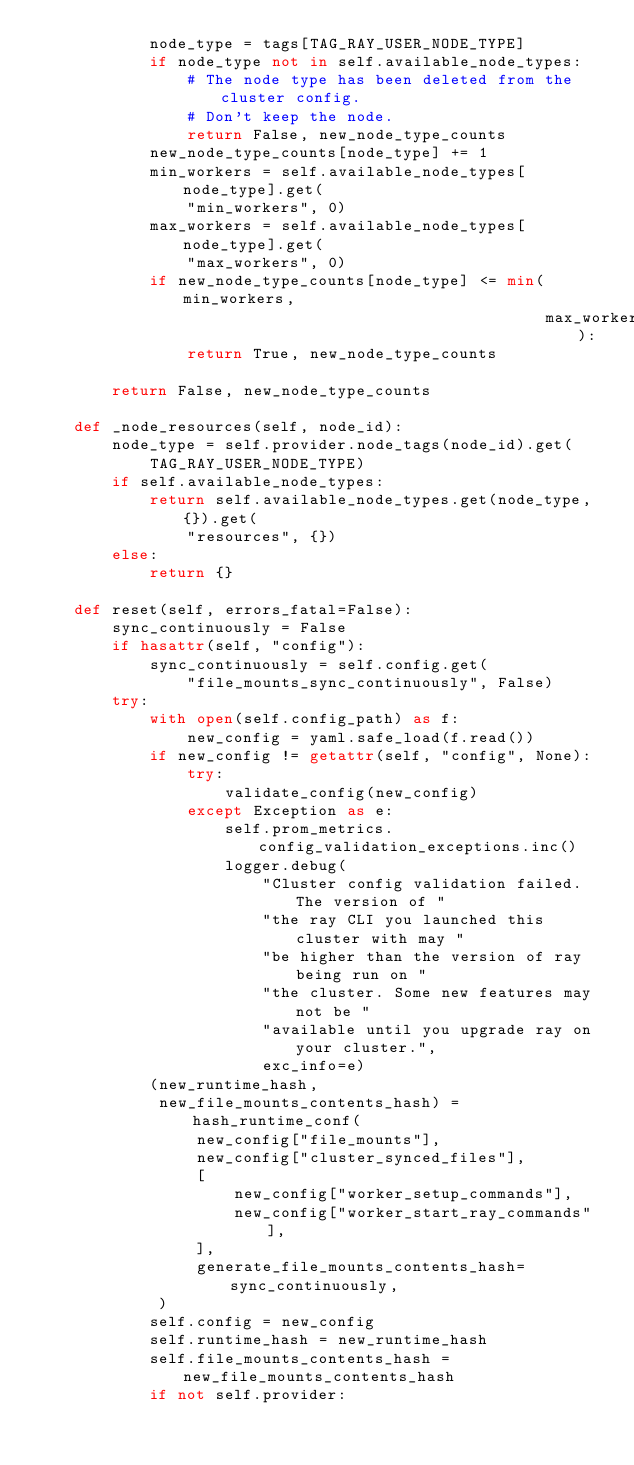Convert code to text. <code><loc_0><loc_0><loc_500><loc_500><_Python_>            node_type = tags[TAG_RAY_USER_NODE_TYPE]
            if node_type not in self.available_node_types:
                # The node type has been deleted from the cluster config.
                # Don't keep the node.
                return False, new_node_type_counts
            new_node_type_counts[node_type] += 1
            min_workers = self.available_node_types[node_type].get(
                "min_workers", 0)
            max_workers = self.available_node_types[node_type].get(
                "max_workers", 0)
            if new_node_type_counts[node_type] <= min(min_workers,
                                                      max_workers):
                return True, new_node_type_counts

        return False, new_node_type_counts

    def _node_resources(self, node_id):
        node_type = self.provider.node_tags(node_id).get(
            TAG_RAY_USER_NODE_TYPE)
        if self.available_node_types:
            return self.available_node_types.get(node_type, {}).get(
                "resources", {})
        else:
            return {}

    def reset(self, errors_fatal=False):
        sync_continuously = False
        if hasattr(self, "config"):
            sync_continuously = self.config.get(
                "file_mounts_sync_continuously", False)
        try:
            with open(self.config_path) as f:
                new_config = yaml.safe_load(f.read())
            if new_config != getattr(self, "config", None):
                try:
                    validate_config(new_config)
                except Exception as e:
                    self.prom_metrics.config_validation_exceptions.inc()
                    logger.debug(
                        "Cluster config validation failed. The version of "
                        "the ray CLI you launched this cluster with may "
                        "be higher than the version of ray being run on "
                        "the cluster. Some new features may not be "
                        "available until you upgrade ray on your cluster.",
                        exc_info=e)
            (new_runtime_hash,
             new_file_mounts_contents_hash) = hash_runtime_conf(
                 new_config["file_mounts"],
                 new_config["cluster_synced_files"],
                 [
                     new_config["worker_setup_commands"],
                     new_config["worker_start_ray_commands"],
                 ],
                 generate_file_mounts_contents_hash=sync_continuously,
             )
            self.config = new_config
            self.runtime_hash = new_runtime_hash
            self.file_mounts_contents_hash = new_file_mounts_contents_hash
            if not self.provider:</code> 